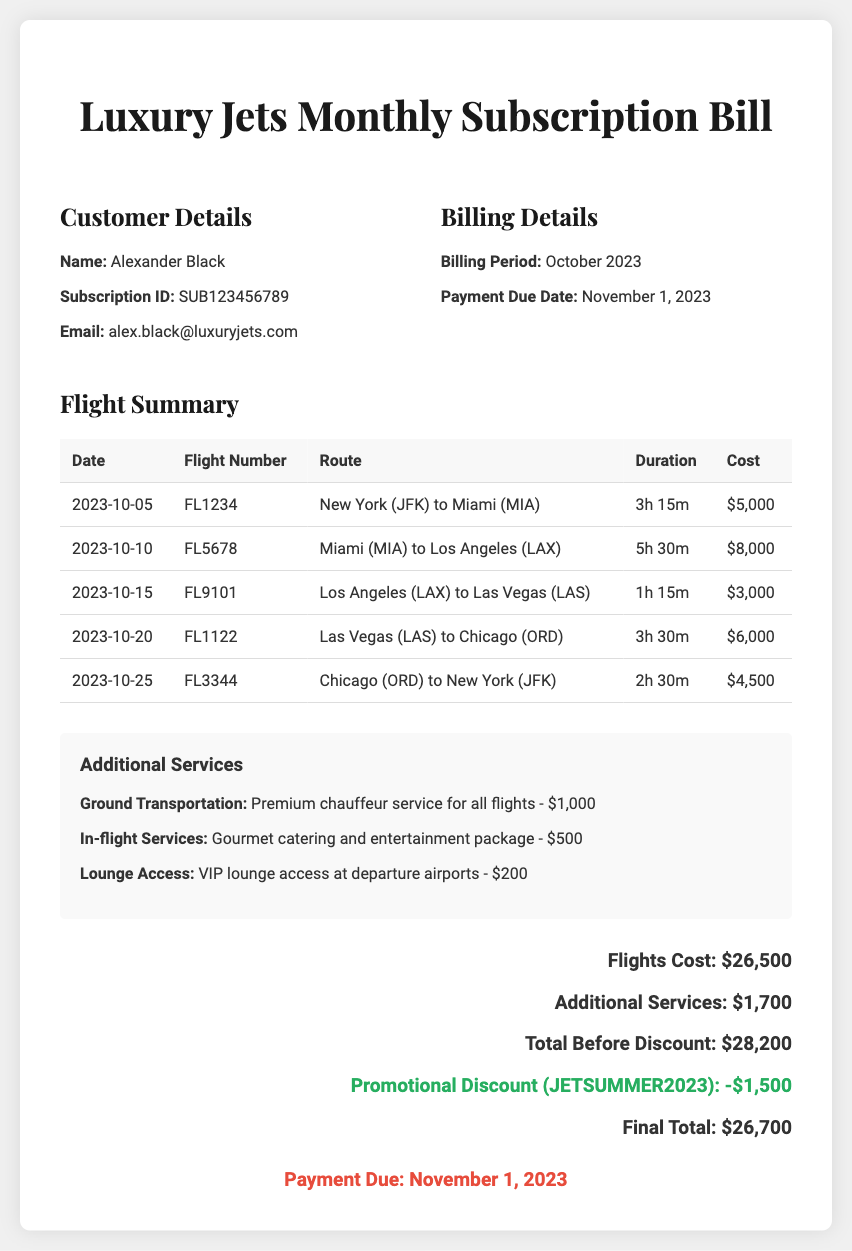What is the name of the customer? The document clearly states the customer's name is Alexander Black.
Answer: Alexander Black How many flights were booked during October 2023? By counting the flight entries in the table, there are five flights booked.
Answer: 5 What was the total cost of the flights? The total flight cost is explicitly listed in the document as $26,500.
Answer: $26,500 What promotional discount was applied to the final bill? The document details a promotional discount of $1,500 under the discount section.
Answer: $1,500 What date is the payment due? The document indicates that the payment is due on November 1, 2023.
Answer: November 1, 2023 What is the total cost for additional services? The total for additional services, including ground transportation, in-flight services, and lounge access, is $1,700.
Answer: $1,700 Which flight had the longest duration? The longest flight duration listed in the table is 5 hours and 30 minutes (Miami to Los Angeles).
Answer: 5h 30m What is the final total after the promotional discount? The final total after applying the discount is provided as $26,700.
Answer: $26,700 What type of lounge access is mentioned in the bill? The document specifies that VIP lounge access is included in the additional services.
Answer: VIP lounge access 